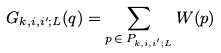Convert formula to latex. <formula><loc_0><loc_0><loc_500><loc_500>G _ { k , i , i ^ { \prime } ; L } ( q ) = \sum _ { p \, \in \, P _ { k , i , i ^ { \prime } ; L } } W ( p )</formula> 